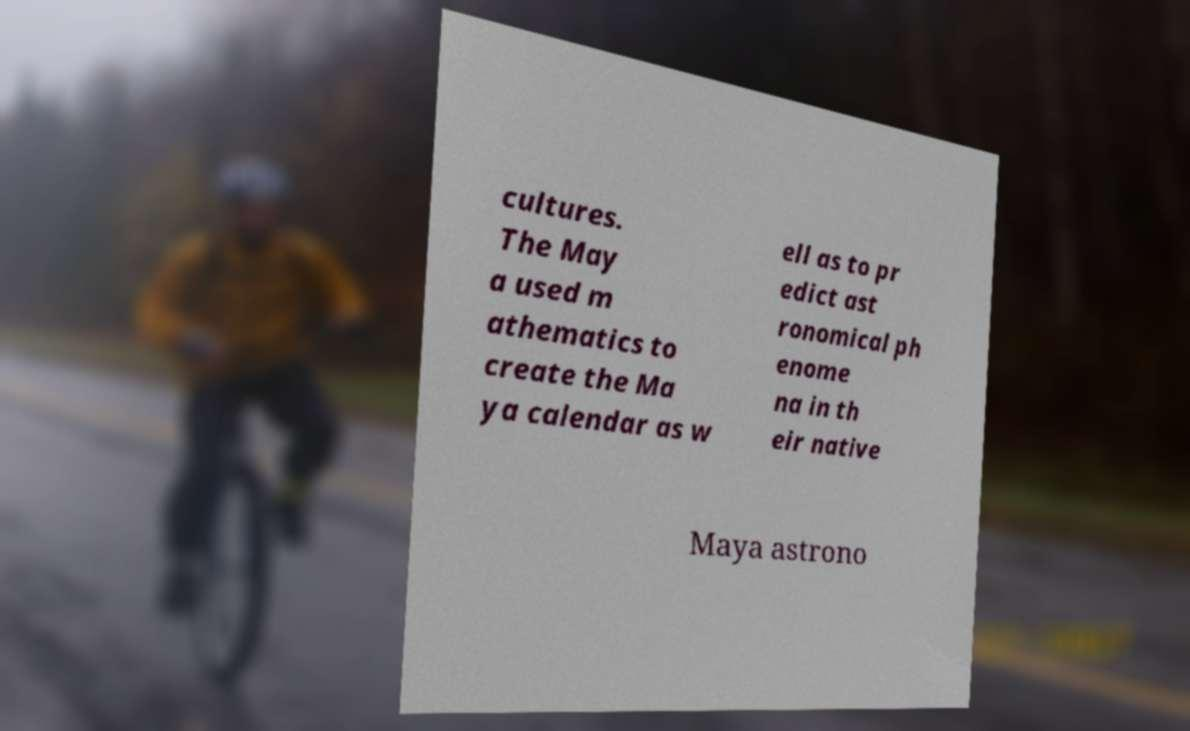Could you extract and type out the text from this image? cultures. The May a used m athematics to create the Ma ya calendar as w ell as to pr edict ast ronomical ph enome na in th eir native Maya astrono 